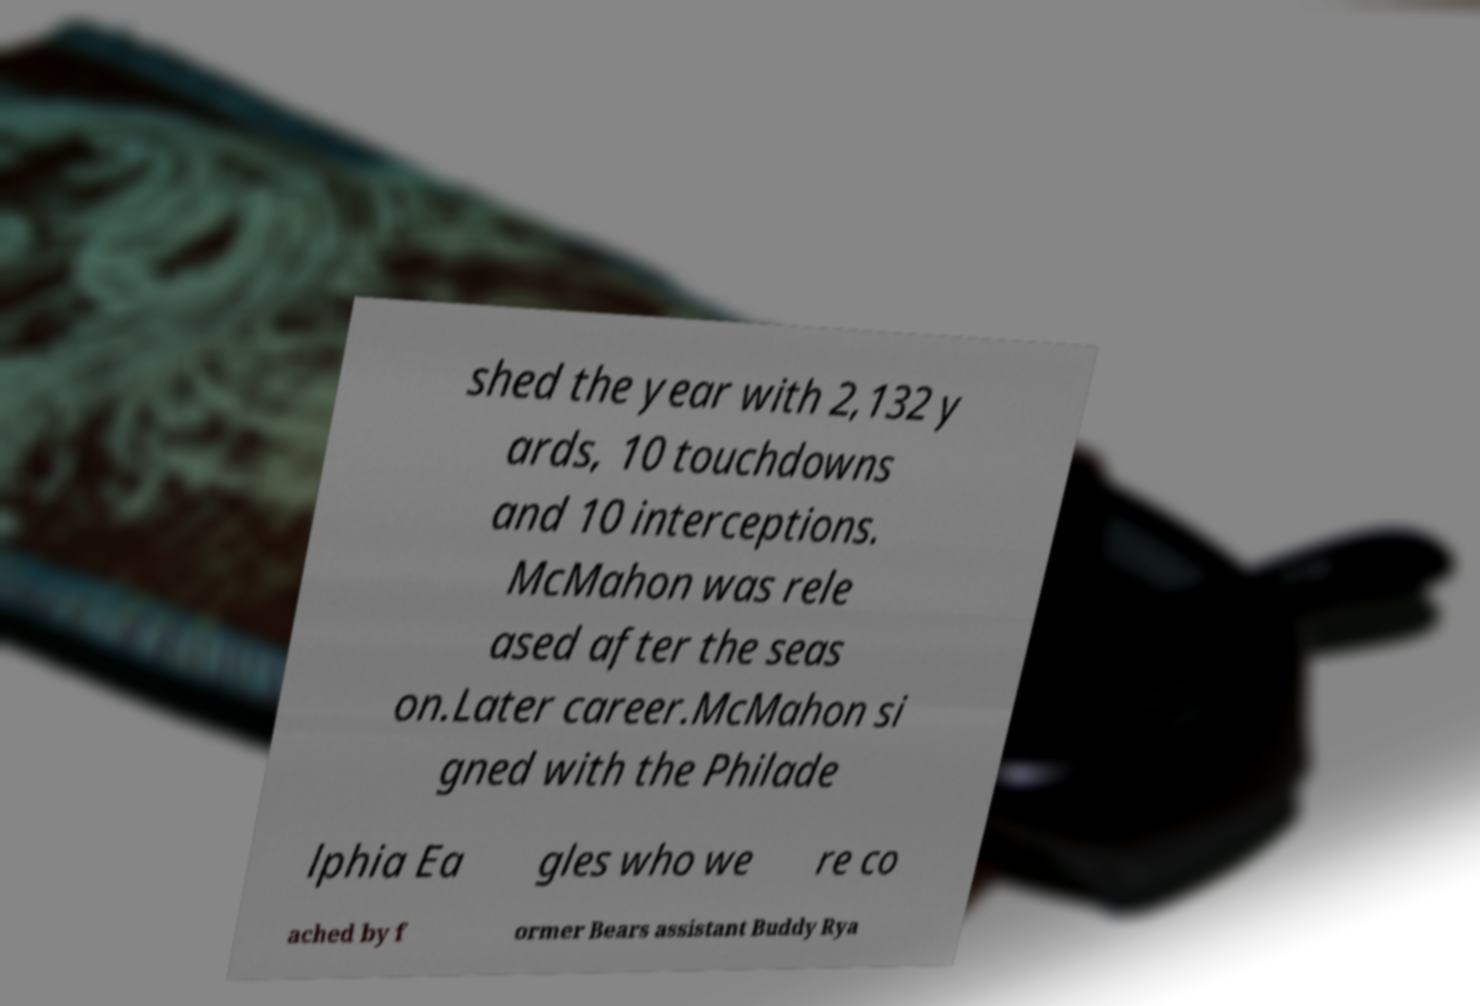Please identify and transcribe the text found in this image. shed the year with 2,132 y ards, 10 touchdowns and 10 interceptions. McMahon was rele ased after the seas on.Later career.McMahon si gned with the Philade lphia Ea gles who we re co ached by f ormer Bears assistant Buddy Rya 